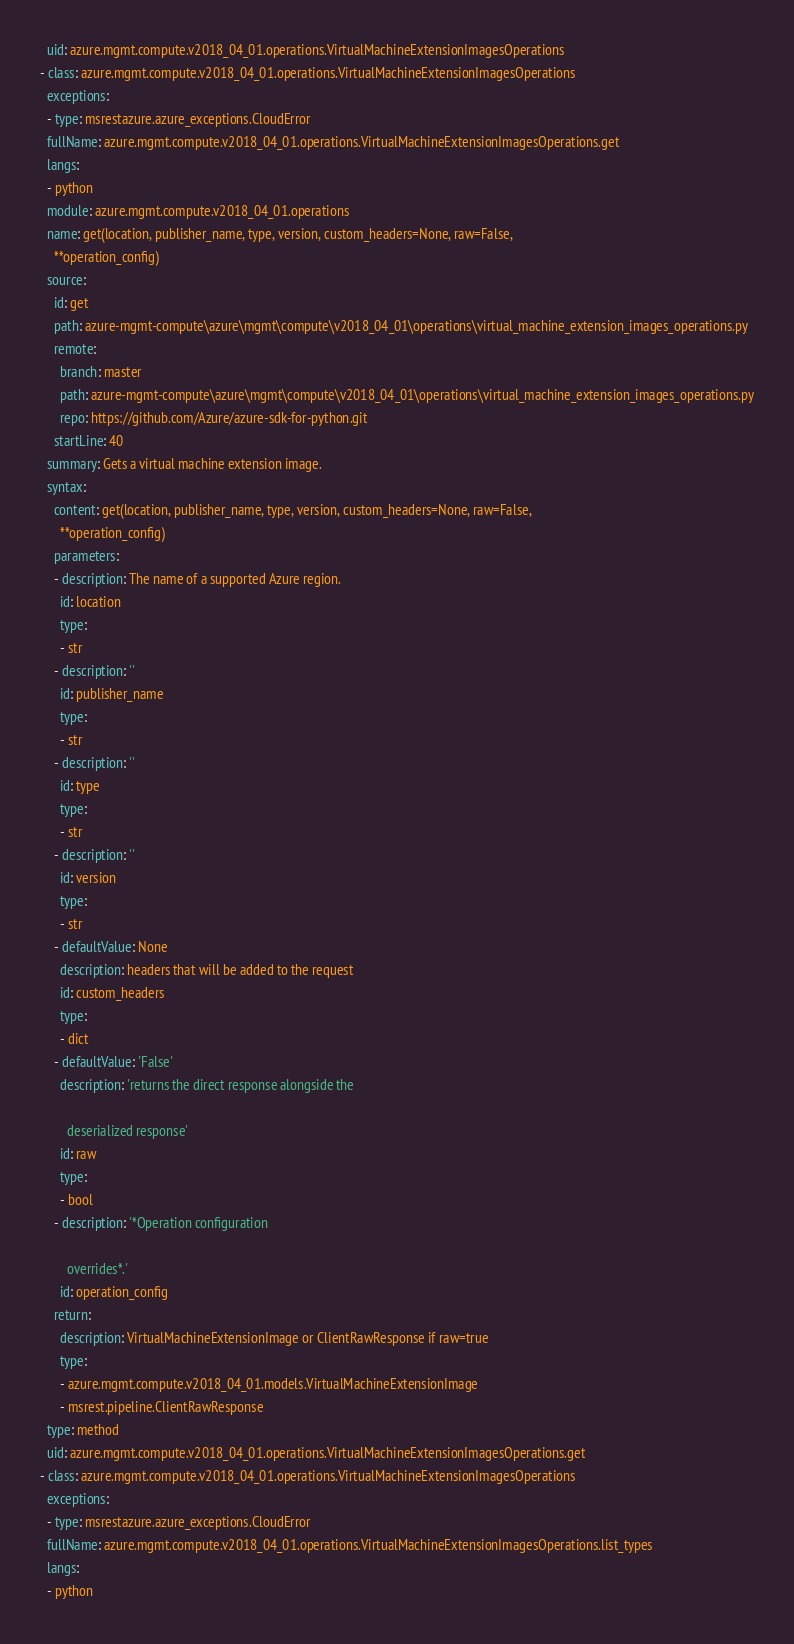<code> <loc_0><loc_0><loc_500><loc_500><_YAML_>  uid: azure.mgmt.compute.v2018_04_01.operations.VirtualMachineExtensionImagesOperations
- class: azure.mgmt.compute.v2018_04_01.operations.VirtualMachineExtensionImagesOperations
  exceptions:
  - type: msrestazure.azure_exceptions.CloudError
  fullName: azure.mgmt.compute.v2018_04_01.operations.VirtualMachineExtensionImagesOperations.get
  langs:
  - python
  module: azure.mgmt.compute.v2018_04_01.operations
  name: get(location, publisher_name, type, version, custom_headers=None, raw=False,
    **operation_config)
  source:
    id: get
    path: azure-mgmt-compute\azure\mgmt\compute\v2018_04_01\operations\virtual_machine_extension_images_operations.py
    remote:
      branch: master
      path: azure-mgmt-compute\azure\mgmt\compute\v2018_04_01\operations\virtual_machine_extension_images_operations.py
      repo: https://github.com/Azure/azure-sdk-for-python.git
    startLine: 40
  summary: Gets a virtual machine extension image.
  syntax:
    content: get(location, publisher_name, type, version, custom_headers=None, raw=False,
      **operation_config)
    parameters:
    - description: The name of a supported Azure region.
      id: location
      type:
      - str
    - description: ''
      id: publisher_name
      type:
      - str
    - description: ''
      id: type
      type:
      - str
    - description: ''
      id: version
      type:
      - str
    - defaultValue: None
      description: headers that will be added to the request
      id: custom_headers
      type:
      - dict
    - defaultValue: 'False'
      description: 'returns the direct response alongside the

        deserialized response'
      id: raw
      type:
      - bool
    - description: '*Operation configuration

        overrides*.'
      id: operation_config
    return:
      description: VirtualMachineExtensionImage or ClientRawResponse if raw=true
      type:
      - azure.mgmt.compute.v2018_04_01.models.VirtualMachineExtensionImage
      - msrest.pipeline.ClientRawResponse
  type: method
  uid: azure.mgmt.compute.v2018_04_01.operations.VirtualMachineExtensionImagesOperations.get
- class: azure.mgmt.compute.v2018_04_01.operations.VirtualMachineExtensionImagesOperations
  exceptions:
  - type: msrestazure.azure_exceptions.CloudError
  fullName: azure.mgmt.compute.v2018_04_01.operations.VirtualMachineExtensionImagesOperations.list_types
  langs:
  - python</code> 